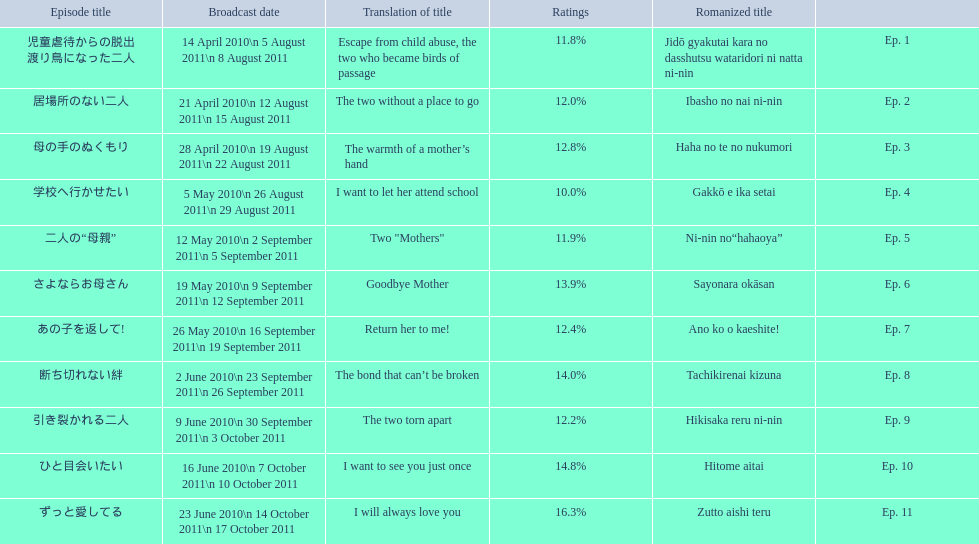Other than the 10th episode, which other episode has a 14% rating? Ep. 8. 